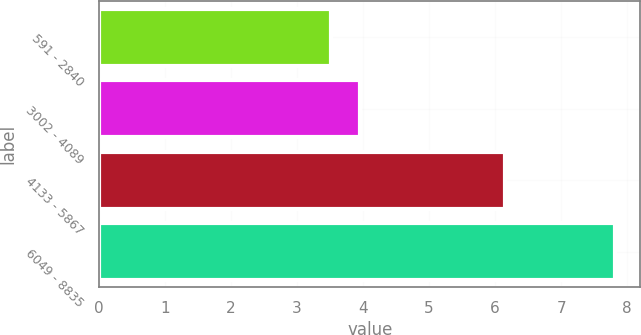Convert chart. <chart><loc_0><loc_0><loc_500><loc_500><bar_chart><fcel>591 - 2840<fcel>3002 - 4089<fcel>4133 - 5867<fcel>6049 - 8835<nl><fcel>3.52<fcel>3.95<fcel>6.15<fcel>7.81<nl></chart> 